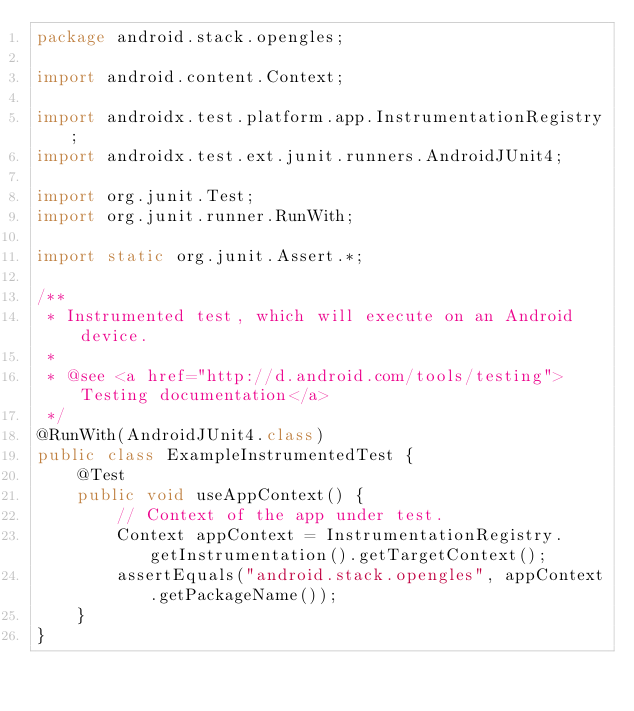<code> <loc_0><loc_0><loc_500><loc_500><_Java_>package android.stack.opengles;

import android.content.Context;

import androidx.test.platform.app.InstrumentationRegistry;
import androidx.test.ext.junit.runners.AndroidJUnit4;

import org.junit.Test;
import org.junit.runner.RunWith;

import static org.junit.Assert.*;

/**
 * Instrumented test, which will execute on an Android device.
 *
 * @see <a href="http://d.android.com/tools/testing">Testing documentation</a>
 */
@RunWith(AndroidJUnit4.class)
public class ExampleInstrumentedTest {
    @Test
    public void useAppContext() {
        // Context of the app under test.
        Context appContext = InstrumentationRegistry.getInstrumentation().getTargetContext();
        assertEquals("android.stack.opengles", appContext.getPackageName());
    }
}</code> 